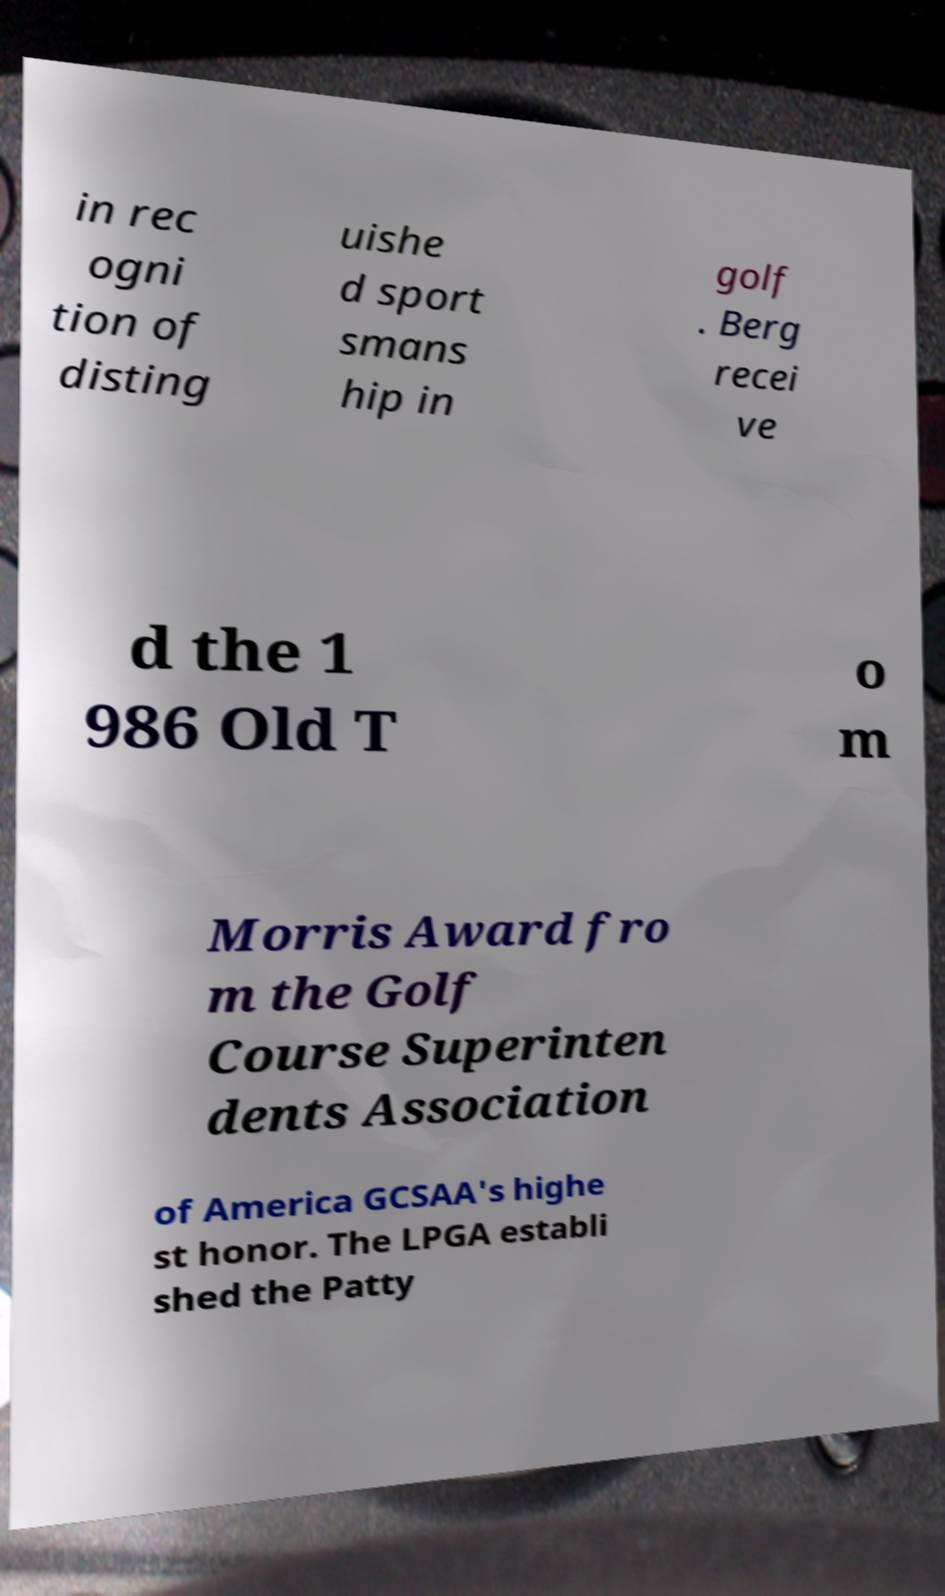Please read and relay the text visible in this image. What does it say? in rec ogni tion of disting uishe d sport smans hip in golf . Berg recei ve d the 1 986 Old T o m Morris Award fro m the Golf Course Superinten dents Association of America GCSAA's highe st honor. The LPGA establi shed the Patty 